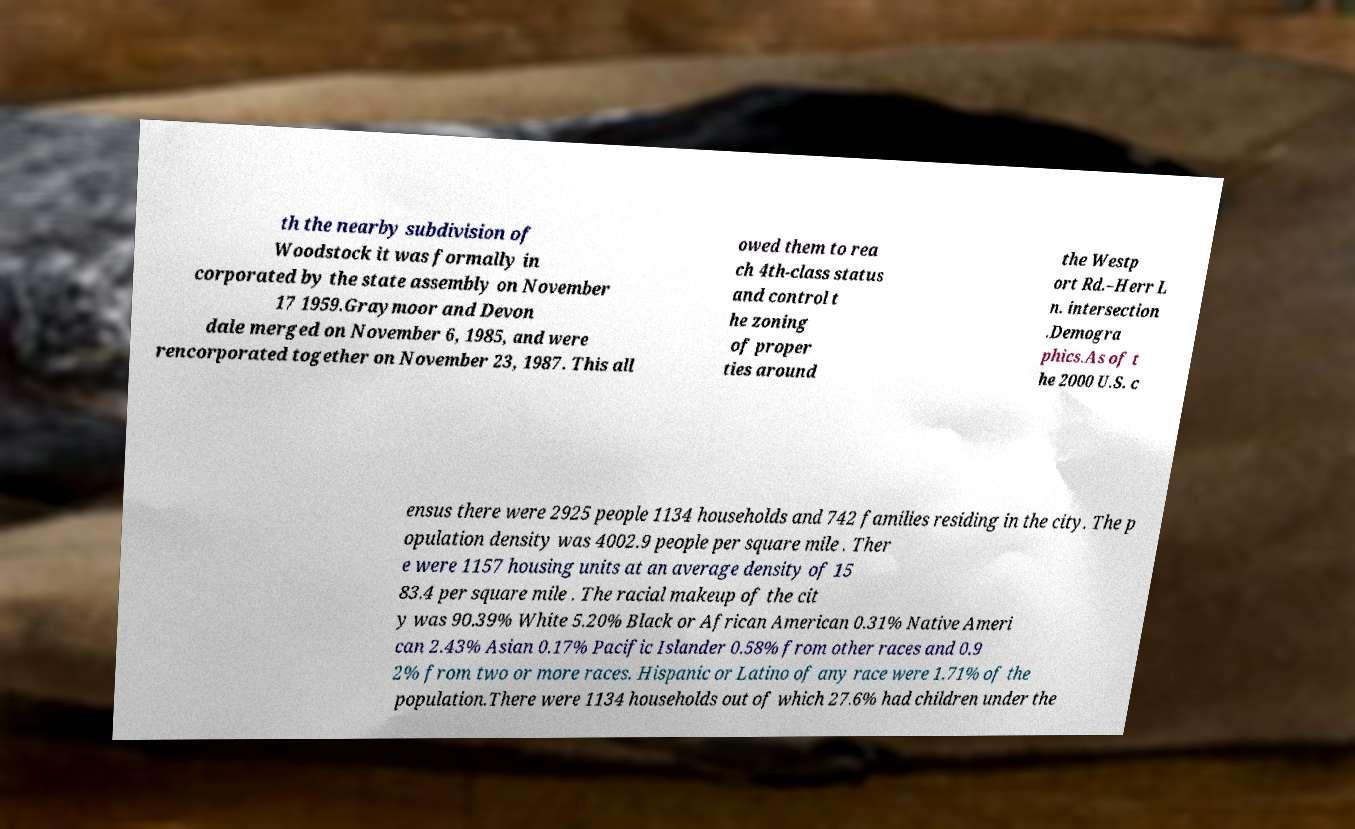Please identify and transcribe the text found in this image. th the nearby subdivision of Woodstock it was formally in corporated by the state assembly on November 17 1959.Graymoor and Devon dale merged on November 6, 1985, and were rencorporated together on November 23, 1987. This all owed them to rea ch 4th-class status and control t he zoning of proper ties around the Westp ort Rd.–Herr L n. intersection .Demogra phics.As of t he 2000 U.S. c ensus there were 2925 people 1134 households and 742 families residing in the city. The p opulation density was 4002.9 people per square mile . Ther e were 1157 housing units at an average density of 15 83.4 per square mile . The racial makeup of the cit y was 90.39% White 5.20% Black or African American 0.31% Native Ameri can 2.43% Asian 0.17% Pacific Islander 0.58% from other races and 0.9 2% from two or more races. Hispanic or Latino of any race were 1.71% of the population.There were 1134 households out of which 27.6% had children under the 